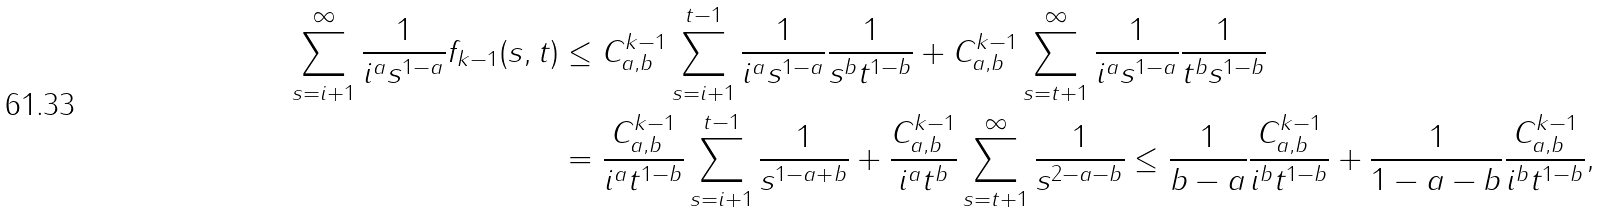Convert formula to latex. <formula><loc_0><loc_0><loc_500><loc_500>\sum _ { s = i + 1 } ^ { \infty } \frac { 1 } { i ^ { a } { s } ^ { 1 - a } } f _ { k - 1 } ( s , t ) & \leq C ^ { k - 1 } _ { a , b } \sum _ { s = i + 1 } ^ { t - 1 } \frac { 1 } { i ^ { a } { s } ^ { 1 - a } } \frac { 1 } { s ^ { b } t ^ { 1 - b } } + C ^ { k - 1 } _ { a , b } \sum _ { s = t + 1 } ^ { \infty } \frac { 1 } { i ^ { a } { s } ^ { 1 - a } } \frac { 1 } { t ^ { b } s ^ { 1 - b } } \\ & = \frac { C ^ { k - 1 } _ { a , b } } { i ^ { a } t ^ { 1 - b } } \sum _ { s = i + 1 } ^ { t - 1 } \frac { 1 } { s ^ { 1 - a + b } } + \frac { C ^ { k - 1 } _ { a , b } } { i ^ { a } t ^ { b } } \sum _ { s = t + 1 } ^ { \infty } \frac { 1 } { { s } ^ { 2 - a - b } } \leq \frac { 1 } { b - a } \frac { C ^ { k - 1 } _ { a , b } } { i ^ { b } t ^ { 1 - b } } + \frac { 1 } { 1 - a - b } \frac { C ^ { k - 1 } _ { a , b } } { i ^ { b } t ^ { 1 - b } } ,</formula> 